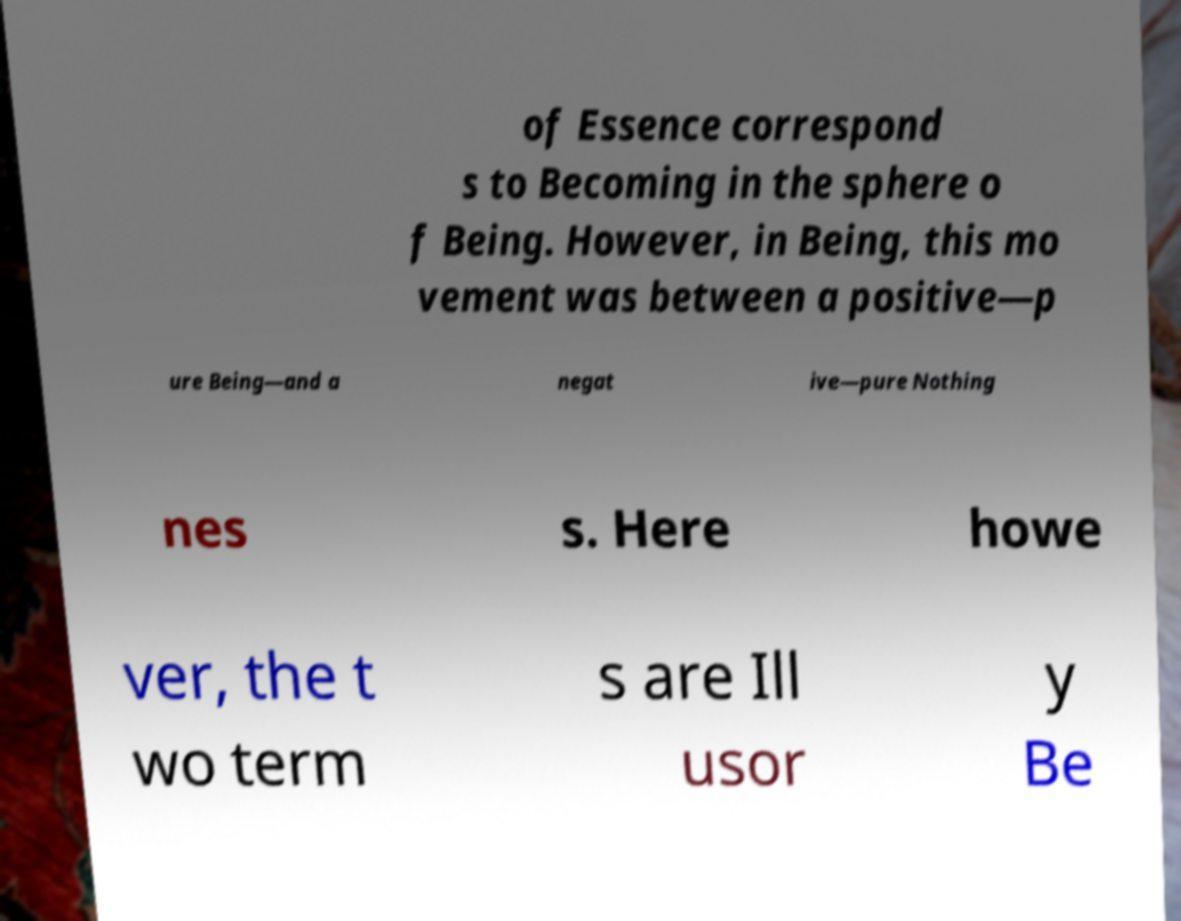Please read and relay the text visible in this image. What does it say? of Essence correspond s to Becoming in the sphere o f Being. However, in Being, this mo vement was between a positive—p ure Being—and a negat ive—pure Nothing nes s. Here howe ver, the t wo term s are Ill usor y Be 